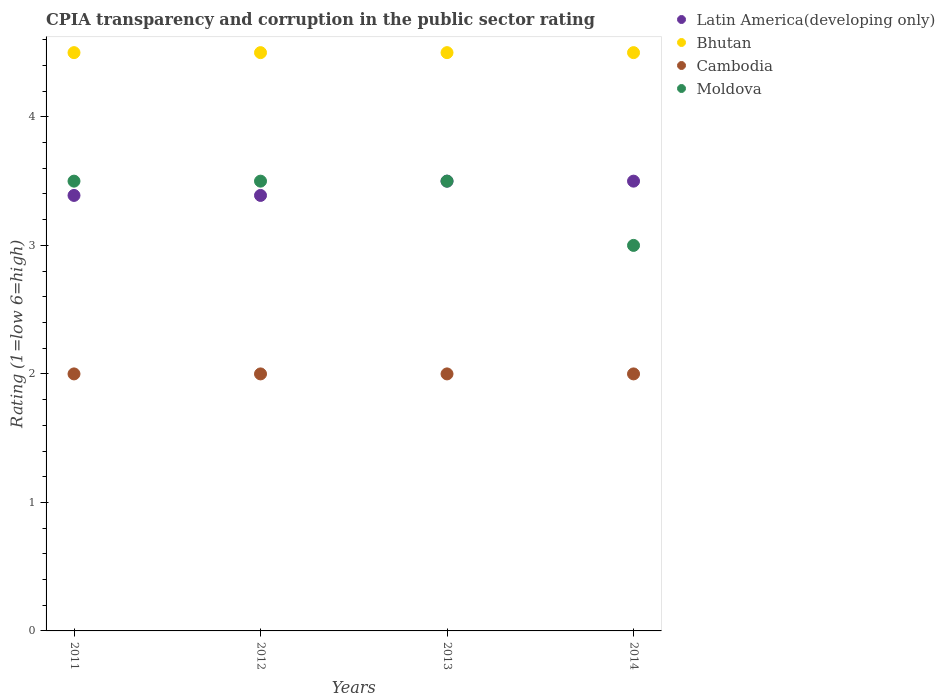Across all years, what is the minimum CPIA rating in Cambodia?
Offer a very short reply. 2. In which year was the CPIA rating in Bhutan maximum?
Your answer should be very brief. 2011. What is the total CPIA rating in Moldova in the graph?
Offer a terse response. 13.5. What is the difference between the CPIA rating in Bhutan in 2011 and that in 2013?
Provide a short and direct response. 0. What is the average CPIA rating in Cambodia per year?
Offer a very short reply. 2. In the year 2013, what is the difference between the CPIA rating in Moldova and CPIA rating in Bhutan?
Keep it short and to the point. -1. What is the ratio of the CPIA rating in Moldova in 2011 to that in 2014?
Give a very brief answer. 1.17. What is the difference between the highest and the second highest CPIA rating in Latin America(developing only)?
Offer a very short reply. 0. What is the difference between the highest and the lowest CPIA rating in Moldova?
Provide a succinct answer. 0.5. Is it the case that in every year, the sum of the CPIA rating in Moldova and CPIA rating in Cambodia  is greater than the CPIA rating in Bhutan?
Your response must be concise. Yes. Is the CPIA rating in Cambodia strictly greater than the CPIA rating in Moldova over the years?
Give a very brief answer. No. Is the CPIA rating in Latin America(developing only) strictly less than the CPIA rating in Bhutan over the years?
Offer a very short reply. Yes. How many dotlines are there?
Provide a short and direct response. 4. Are the values on the major ticks of Y-axis written in scientific E-notation?
Offer a very short reply. No. Does the graph contain any zero values?
Provide a succinct answer. No. Does the graph contain grids?
Your answer should be very brief. No. How many legend labels are there?
Your response must be concise. 4. What is the title of the graph?
Provide a succinct answer. CPIA transparency and corruption in the public sector rating. What is the Rating (1=low 6=high) in Latin America(developing only) in 2011?
Your response must be concise. 3.39. What is the Rating (1=low 6=high) in Latin America(developing only) in 2012?
Provide a succinct answer. 3.39. What is the Rating (1=low 6=high) of Moldova in 2012?
Offer a terse response. 3.5. What is the Rating (1=low 6=high) of Latin America(developing only) in 2013?
Offer a terse response. 3.5. What is the Rating (1=low 6=high) of Bhutan in 2013?
Provide a succinct answer. 4.5. What is the Rating (1=low 6=high) in Cambodia in 2013?
Offer a terse response. 2. What is the Rating (1=low 6=high) of Moldova in 2013?
Give a very brief answer. 3.5. What is the Rating (1=low 6=high) of Bhutan in 2014?
Ensure brevity in your answer.  4.5. What is the Rating (1=low 6=high) of Cambodia in 2014?
Ensure brevity in your answer.  2. What is the Rating (1=low 6=high) in Moldova in 2014?
Make the answer very short. 3. Across all years, what is the maximum Rating (1=low 6=high) of Cambodia?
Make the answer very short. 2. Across all years, what is the minimum Rating (1=low 6=high) in Latin America(developing only)?
Your response must be concise. 3.39. Across all years, what is the minimum Rating (1=low 6=high) of Bhutan?
Provide a succinct answer. 4.5. Across all years, what is the minimum Rating (1=low 6=high) of Cambodia?
Your answer should be very brief. 2. What is the total Rating (1=low 6=high) in Latin America(developing only) in the graph?
Provide a succinct answer. 13.78. What is the total Rating (1=low 6=high) of Bhutan in the graph?
Make the answer very short. 18. What is the difference between the Rating (1=low 6=high) in Bhutan in 2011 and that in 2012?
Your answer should be compact. 0. What is the difference between the Rating (1=low 6=high) of Latin America(developing only) in 2011 and that in 2013?
Offer a terse response. -0.11. What is the difference between the Rating (1=low 6=high) in Moldova in 2011 and that in 2013?
Ensure brevity in your answer.  0. What is the difference between the Rating (1=low 6=high) in Latin America(developing only) in 2011 and that in 2014?
Offer a terse response. -0.11. What is the difference between the Rating (1=low 6=high) of Cambodia in 2011 and that in 2014?
Offer a terse response. 0. What is the difference between the Rating (1=low 6=high) of Latin America(developing only) in 2012 and that in 2013?
Ensure brevity in your answer.  -0.11. What is the difference between the Rating (1=low 6=high) of Bhutan in 2012 and that in 2013?
Your response must be concise. 0. What is the difference between the Rating (1=low 6=high) in Cambodia in 2012 and that in 2013?
Offer a very short reply. 0. What is the difference between the Rating (1=low 6=high) of Moldova in 2012 and that in 2013?
Offer a terse response. 0. What is the difference between the Rating (1=low 6=high) of Latin America(developing only) in 2012 and that in 2014?
Keep it short and to the point. -0.11. What is the difference between the Rating (1=low 6=high) of Bhutan in 2012 and that in 2014?
Your answer should be very brief. 0. What is the difference between the Rating (1=low 6=high) in Moldova in 2012 and that in 2014?
Your response must be concise. 0.5. What is the difference between the Rating (1=low 6=high) of Latin America(developing only) in 2013 and that in 2014?
Offer a very short reply. 0. What is the difference between the Rating (1=low 6=high) of Bhutan in 2013 and that in 2014?
Your response must be concise. 0. What is the difference between the Rating (1=low 6=high) of Latin America(developing only) in 2011 and the Rating (1=low 6=high) of Bhutan in 2012?
Make the answer very short. -1.11. What is the difference between the Rating (1=low 6=high) of Latin America(developing only) in 2011 and the Rating (1=low 6=high) of Cambodia in 2012?
Your response must be concise. 1.39. What is the difference between the Rating (1=low 6=high) in Latin America(developing only) in 2011 and the Rating (1=low 6=high) in Moldova in 2012?
Your answer should be compact. -0.11. What is the difference between the Rating (1=low 6=high) in Bhutan in 2011 and the Rating (1=low 6=high) in Cambodia in 2012?
Your answer should be compact. 2.5. What is the difference between the Rating (1=low 6=high) of Latin America(developing only) in 2011 and the Rating (1=low 6=high) of Bhutan in 2013?
Your answer should be very brief. -1.11. What is the difference between the Rating (1=low 6=high) in Latin America(developing only) in 2011 and the Rating (1=low 6=high) in Cambodia in 2013?
Give a very brief answer. 1.39. What is the difference between the Rating (1=low 6=high) of Latin America(developing only) in 2011 and the Rating (1=low 6=high) of Moldova in 2013?
Provide a succinct answer. -0.11. What is the difference between the Rating (1=low 6=high) of Bhutan in 2011 and the Rating (1=low 6=high) of Moldova in 2013?
Provide a succinct answer. 1. What is the difference between the Rating (1=low 6=high) of Latin America(developing only) in 2011 and the Rating (1=low 6=high) of Bhutan in 2014?
Provide a succinct answer. -1.11. What is the difference between the Rating (1=low 6=high) in Latin America(developing only) in 2011 and the Rating (1=low 6=high) in Cambodia in 2014?
Offer a terse response. 1.39. What is the difference between the Rating (1=low 6=high) in Latin America(developing only) in 2011 and the Rating (1=low 6=high) in Moldova in 2014?
Make the answer very short. 0.39. What is the difference between the Rating (1=low 6=high) in Bhutan in 2011 and the Rating (1=low 6=high) in Cambodia in 2014?
Offer a terse response. 2.5. What is the difference between the Rating (1=low 6=high) in Latin America(developing only) in 2012 and the Rating (1=low 6=high) in Bhutan in 2013?
Ensure brevity in your answer.  -1.11. What is the difference between the Rating (1=low 6=high) in Latin America(developing only) in 2012 and the Rating (1=low 6=high) in Cambodia in 2013?
Provide a short and direct response. 1.39. What is the difference between the Rating (1=low 6=high) of Latin America(developing only) in 2012 and the Rating (1=low 6=high) of Moldova in 2013?
Make the answer very short. -0.11. What is the difference between the Rating (1=low 6=high) of Bhutan in 2012 and the Rating (1=low 6=high) of Cambodia in 2013?
Keep it short and to the point. 2.5. What is the difference between the Rating (1=low 6=high) in Latin America(developing only) in 2012 and the Rating (1=low 6=high) in Bhutan in 2014?
Ensure brevity in your answer.  -1.11. What is the difference between the Rating (1=low 6=high) of Latin America(developing only) in 2012 and the Rating (1=low 6=high) of Cambodia in 2014?
Keep it short and to the point. 1.39. What is the difference between the Rating (1=low 6=high) of Latin America(developing only) in 2012 and the Rating (1=low 6=high) of Moldova in 2014?
Your answer should be compact. 0.39. What is the difference between the Rating (1=low 6=high) of Cambodia in 2012 and the Rating (1=low 6=high) of Moldova in 2014?
Provide a short and direct response. -1. What is the difference between the Rating (1=low 6=high) of Latin America(developing only) in 2013 and the Rating (1=low 6=high) of Bhutan in 2014?
Give a very brief answer. -1. What is the difference between the Rating (1=low 6=high) of Latin America(developing only) in 2013 and the Rating (1=low 6=high) of Cambodia in 2014?
Your answer should be very brief. 1.5. What is the difference between the Rating (1=low 6=high) in Latin America(developing only) in 2013 and the Rating (1=low 6=high) in Moldova in 2014?
Provide a short and direct response. 0.5. What is the difference between the Rating (1=low 6=high) of Bhutan in 2013 and the Rating (1=low 6=high) of Cambodia in 2014?
Offer a very short reply. 2.5. What is the average Rating (1=low 6=high) in Latin America(developing only) per year?
Ensure brevity in your answer.  3.44. What is the average Rating (1=low 6=high) in Bhutan per year?
Offer a very short reply. 4.5. What is the average Rating (1=low 6=high) in Cambodia per year?
Offer a terse response. 2. What is the average Rating (1=low 6=high) of Moldova per year?
Your answer should be compact. 3.38. In the year 2011, what is the difference between the Rating (1=low 6=high) of Latin America(developing only) and Rating (1=low 6=high) of Bhutan?
Ensure brevity in your answer.  -1.11. In the year 2011, what is the difference between the Rating (1=low 6=high) of Latin America(developing only) and Rating (1=low 6=high) of Cambodia?
Your answer should be very brief. 1.39. In the year 2011, what is the difference between the Rating (1=low 6=high) of Latin America(developing only) and Rating (1=low 6=high) of Moldova?
Your answer should be compact. -0.11. In the year 2011, what is the difference between the Rating (1=low 6=high) of Bhutan and Rating (1=low 6=high) of Cambodia?
Offer a terse response. 2.5. In the year 2011, what is the difference between the Rating (1=low 6=high) in Bhutan and Rating (1=low 6=high) in Moldova?
Your response must be concise. 1. In the year 2012, what is the difference between the Rating (1=low 6=high) of Latin America(developing only) and Rating (1=low 6=high) of Bhutan?
Give a very brief answer. -1.11. In the year 2012, what is the difference between the Rating (1=low 6=high) in Latin America(developing only) and Rating (1=low 6=high) in Cambodia?
Offer a terse response. 1.39. In the year 2012, what is the difference between the Rating (1=low 6=high) of Latin America(developing only) and Rating (1=low 6=high) of Moldova?
Make the answer very short. -0.11. In the year 2012, what is the difference between the Rating (1=low 6=high) of Bhutan and Rating (1=low 6=high) of Cambodia?
Your answer should be compact. 2.5. In the year 2012, what is the difference between the Rating (1=low 6=high) of Bhutan and Rating (1=low 6=high) of Moldova?
Your response must be concise. 1. In the year 2013, what is the difference between the Rating (1=low 6=high) in Latin America(developing only) and Rating (1=low 6=high) in Bhutan?
Your answer should be very brief. -1. In the year 2013, what is the difference between the Rating (1=low 6=high) of Latin America(developing only) and Rating (1=low 6=high) of Moldova?
Offer a very short reply. 0. In the year 2013, what is the difference between the Rating (1=low 6=high) of Bhutan and Rating (1=low 6=high) of Cambodia?
Your answer should be compact. 2.5. In the year 2013, what is the difference between the Rating (1=low 6=high) in Cambodia and Rating (1=low 6=high) in Moldova?
Ensure brevity in your answer.  -1.5. In the year 2014, what is the difference between the Rating (1=low 6=high) of Latin America(developing only) and Rating (1=low 6=high) of Moldova?
Provide a succinct answer. 0.5. In the year 2014, what is the difference between the Rating (1=low 6=high) in Bhutan and Rating (1=low 6=high) in Cambodia?
Ensure brevity in your answer.  2.5. What is the ratio of the Rating (1=low 6=high) in Latin America(developing only) in 2011 to that in 2012?
Your answer should be very brief. 1. What is the ratio of the Rating (1=low 6=high) of Cambodia in 2011 to that in 2012?
Your answer should be compact. 1. What is the ratio of the Rating (1=low 6=high) in Moldova in 2011 to that in 2012?
Ensure brevity in your answer.  1. What is the ratio of the Rating (1=low 6=high) of Latin America(developing only) in 2011 to that in 2013?
Offer a very short reply. 0.97. What is the ratio of the Rating (1=low 6=high) of Latin America(developing only) in 2011 to that in 2014?
Provide a succinct answer. 0.97. What is the ratio of the Rating (1=low 6=high) in Bhutan in 2011 to that in 2014?
Your answer should be very brief. 1. What is the ratio of the Rating (1=low 6=high) in Cambodia in 2011 to that in 2014?
Your response must be concise. 1. What is the ratio of the Rating (1=low 6=high) in Latin America(developing only) in 2012 to that in 2013?
Ensure brevity in your answer.  0.97. What is the ratio of the Rating (1=low 6=high) of Latin America(developing only) in 2012 to that in 2014?
Offer a very short reply. 0.97. What is the ratio of the Rating (1=low 6=high) in Moldova in 2012 to that in 2014?
Your response must be concise. 1.17. What is the ratio of the Rating (1=low 6=high) in Latin America(developing only) in 2013 to that in 2014?
Offer a very short reply. 1. What is the ratio of the Rating (1=low 6=high) in Bhutan in 2013 to that in 2014?
Ensure brevity in your answer.  1. What is the ratio of the Rating (1=low 6=high) of Moldova in 2013 to that in 2014?
Your answer should be very brief. 1.17. What is the difference between the highest and the second highest Rating (1=low 6=high) of Latin America(developing only)?
Make the answer very short. 0. What is the difference between the highest and the lowest Rating (1=low 6=high) of Cambodia?
Provide a short and direct response. 0. What is the difference between the highest and the lowest Rating (1=low 6=high) of Moldova?
Provide a succinct answer. 0.5. 